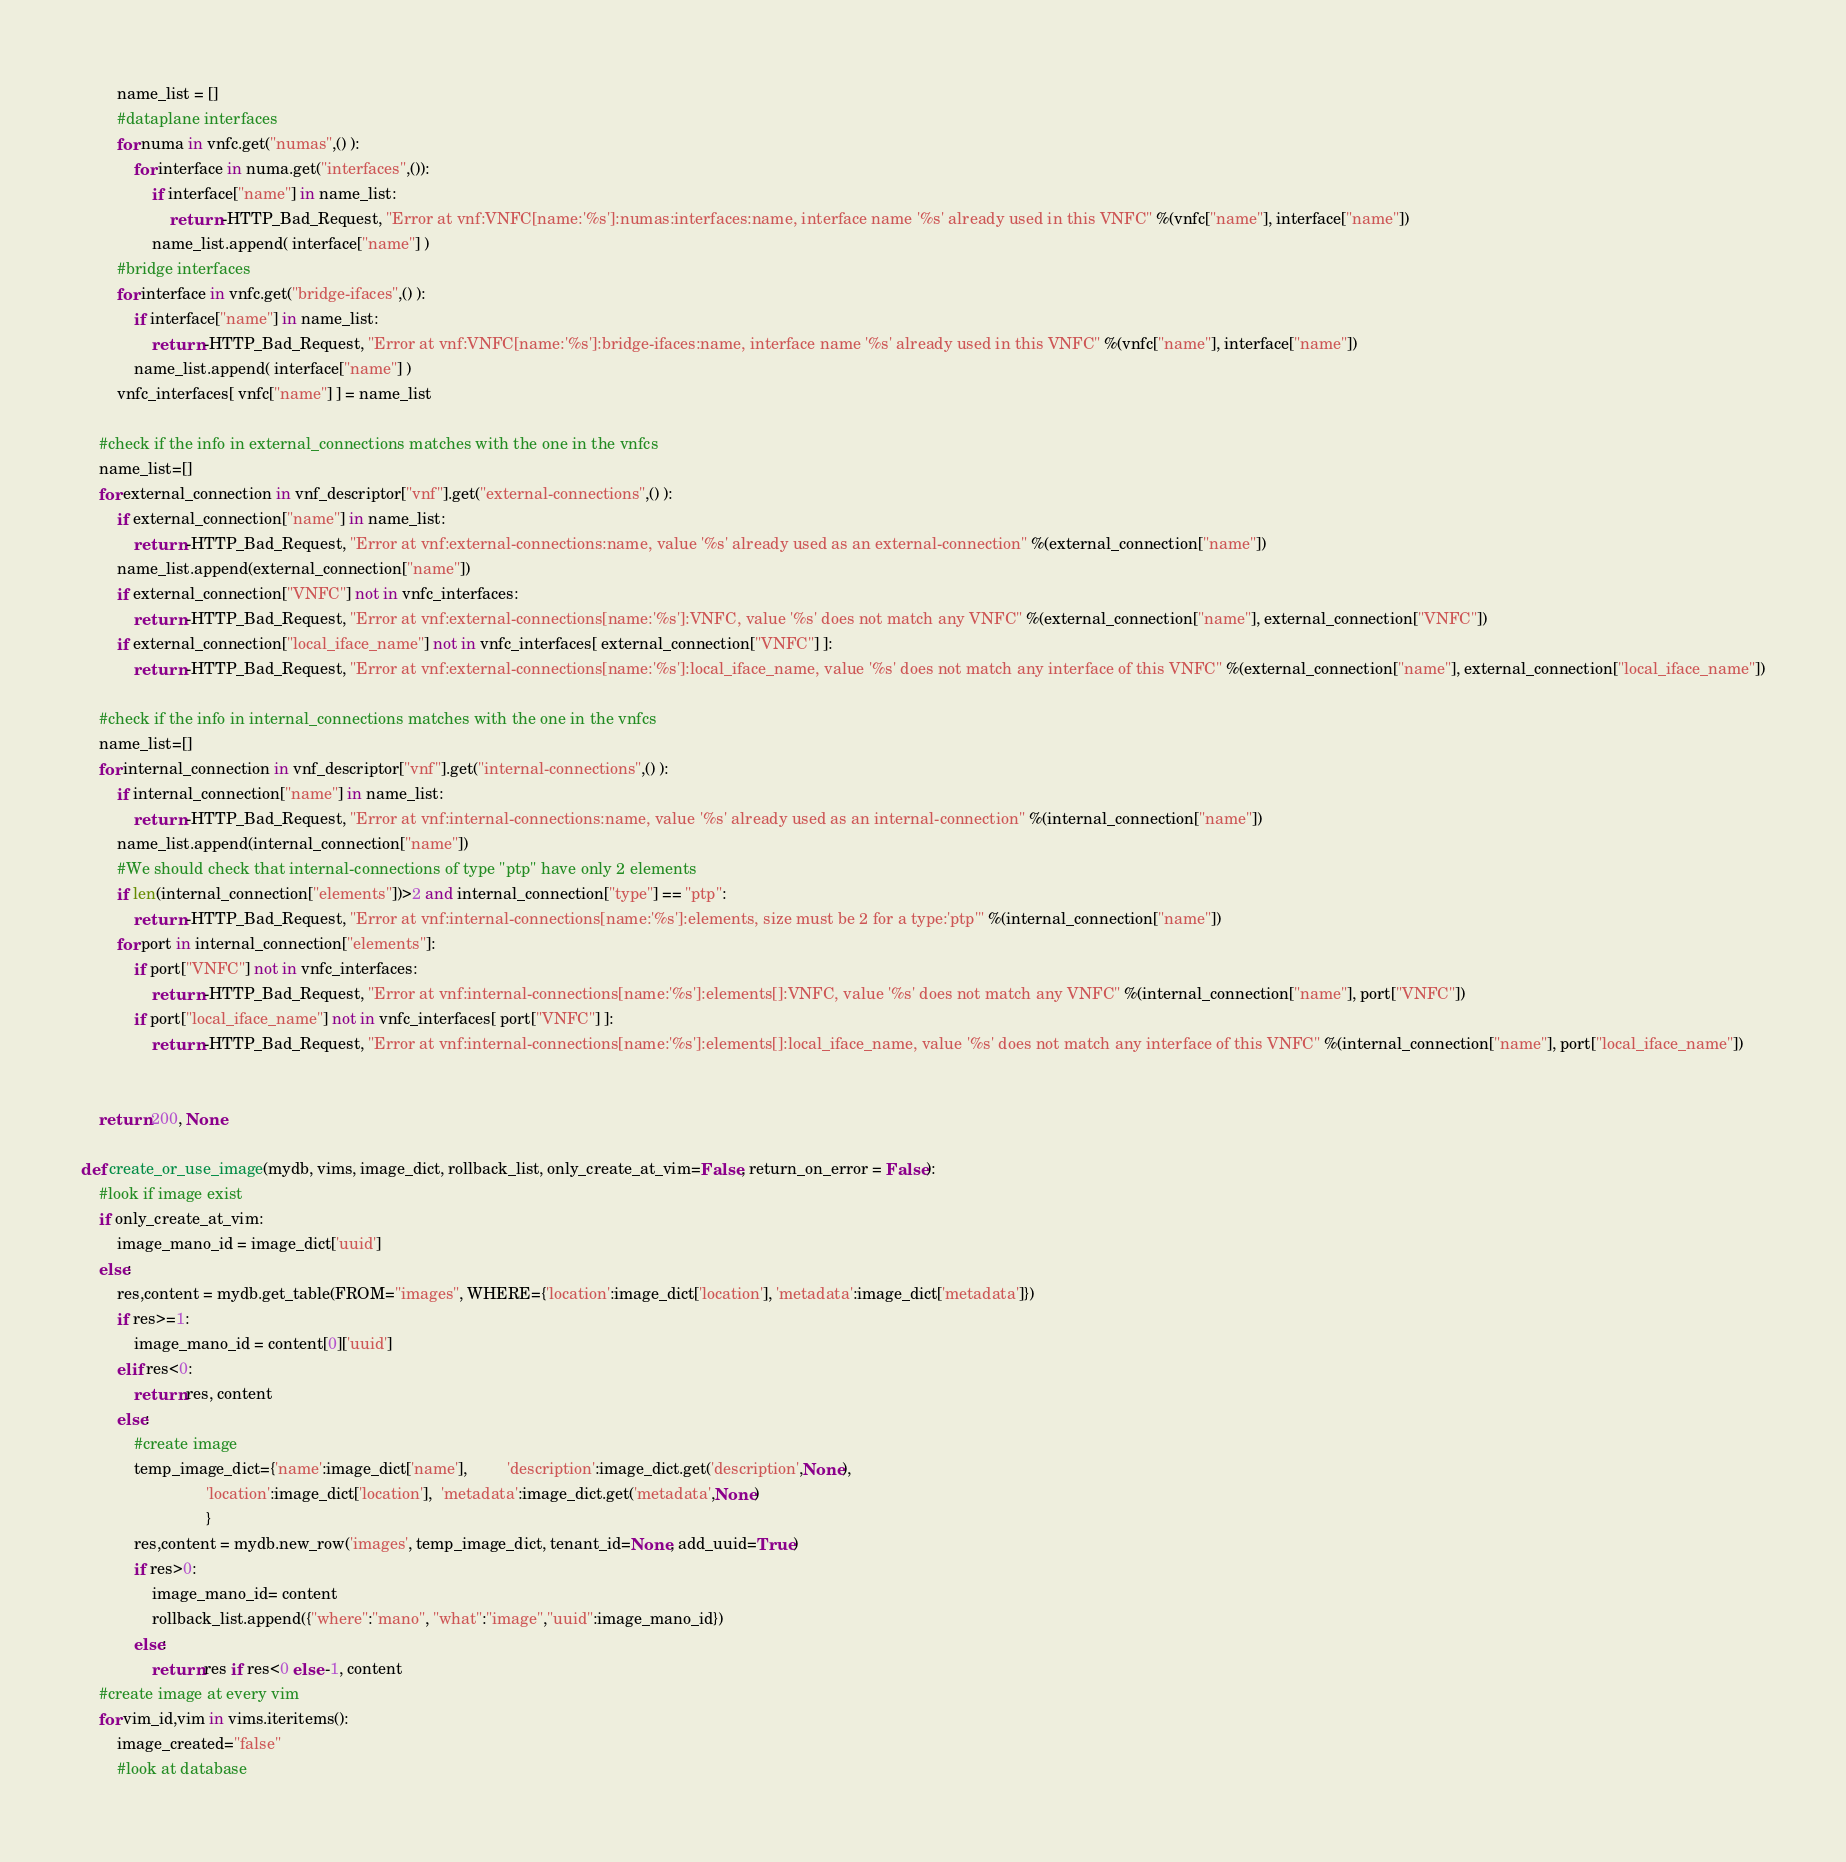<code> <loc_0><loc_0><loc_500><loc_500><_Python_>        name_list = []
        #dataplane interfaces
        for numa in vnfc.get("numas",() ):
            for interface in numa.get("interfaces",()):
                if interface["name"] in name_list:
                    return -HTTP_Bad_Request, "Error at vnf:VNFC[name:'%s']:numas:interfaces:name, interface name '%s' already used in this VNFC" %(vnfc["name"], interface["name"])
                name_list.append( interface["name"] ) 
        #bridge interfaces
        for interface in vnfc.get("bridge-ifaces",() ):
            if interface["name"] in name_list:
                return -HTTP_Bad_Request, "Error at vnf:VNFC[name:'%s']:bridge-ifaces:name, interface name '%s' already used in this VNFC" %(vnfc["name"], interface["name"])
            name_list.append( interface["name"] ) 
        vnfc_interfaces[ vnfc["name"] ] = name_list
    
    #check if the info in external_connections matches with the one in the vnfcs
    name_list=[]
    for external_connection in vnf_descriptor["vnf"].get("external-connections",() ):
        if external_connection["name"] in name_list:
            return -HTTP_Bad_Request, "Error at vnf:external-connections:name, value '%s' already used as an external-connection" %(external_connection["name"])
        name_list.append(external_connection["name"])
        if external_connection["VNFC"] not in vnfc_interfaces:
            return -HTTP_Bad_Request, "Error at vnf:external-connections[name:'%s']:VNFC, value '%s' does not match any VNFC" %(external_connection["name"], external_connection["VNFC"])
        if external_connection["local_iface_name"] not in vnfc_interfaces[ external_connection["VNFC"] ]:
            return -HTTP_Bad_Request, "Error at vnf:external-connections[name:'%s']:local_iface_name, value '%s' does not match any interface of this VNFC" %(external_connection["name"], external_connection["local_iface_name"])
    
    #check if the info in internal_connections matches with the one in the vnfcs
    name_list=[]
    for internal_connection in vnf_descriptor["vnf"].get("internal-connections",() ):
        if internal_connection["name"] in name_list:
            return -HTTP_Bad_Request, "Error at vnf:internal-connections:name, value '%s' already used as an internal-connection" %(internal_connection["name"])
        name_list.append(internal_connection["name"])
        #We should check that internal-connections of type "ptp" have only 2 elements
        if len(internal_connection["elements"])>2 and internal_connection["type"] == "ptp":
            return -HTTP_Bad_Request, "Error at vnf:internal-connections[name:'%s']:elements, size must be 2 for a type:'ptp'" %(internal_connection["name"])
        for port in internal_connection["elements"]:
            if port["VNFC"] not in vnfc_interfaces:
                return -HTTP_Bad_Request, "Error at vnf:internal-connections[name:'%s']:elements[]:VNFC, value '%s' does not match any VNFC" %(internal_connection["name"], port["VNFC"])
            if port["local_iface_name"] not in vnfc_interfaces[ port["VNFC"] ]:
                return -HTTP_Bad_Request, "Error at vnf:internal-connections[name:'%s']:elements[]:local_iface_name, value '%s' does not match any interface of this VNFC" %(internal_connection["name"], port["local_iface_name"])

    
    return 200, None

def create_or_use_image(mydb, vims, image_dict, rollback_list, only_create_at_vim=False, return_on_error = False):
    #look if image exist
    if only_create_at_vim:
        image_mano_id = image_dict['uuid']
    else:
        res,content = mydb.get_table(FROM="images", WHERE={'location':image_dict['location'], 'metadata':image_dict['metadata']})
        if res>=1:
            image_mano_id = content[0]['uuid']
        elif res<0:
            return res, content
        else:
            #create image
            temp_image_dict={'name':image_dict['name'],         'description':image_dict.get('description',None),
                            'location':image_dict['location'],  'metadata':image_dict.get('metadata',None)
                            }
            res,content = mydb.new_row('images', temp_image_dict, tenant_id=None, add_uuid=True)
            if res>0:
                image_mano_id= content
                rollback_list.append({"where":"mano", "what":"image","uuid":image_mano_id})
            else:
                return res if res<0 else -1, content
    #create image at every vim
    for vim_id,vim in vims.iteritems():
        image_created="false"
        #look at database</code> 